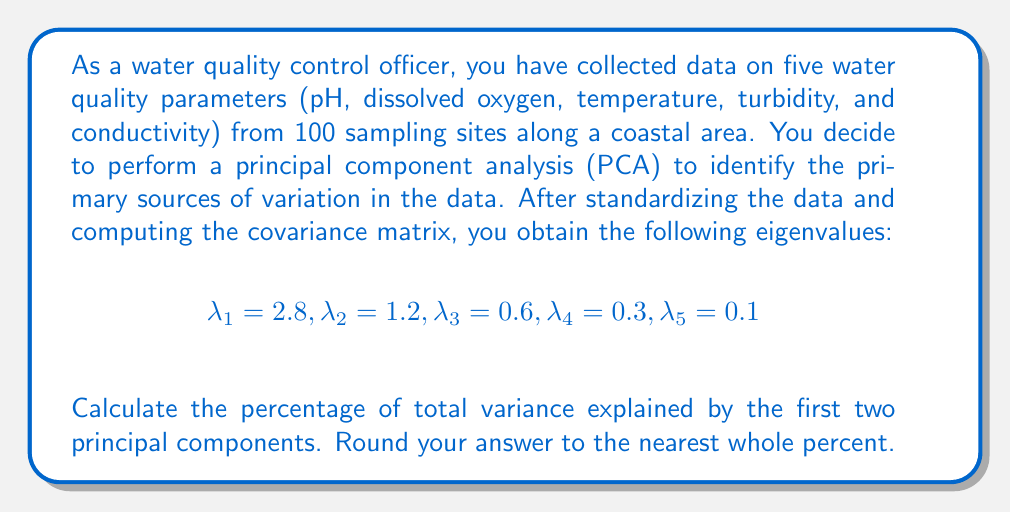Can you answer this question? To solve this problem, we need to follow these steps:

1) First, recall that in PCA, each eigenvalue represents the amount of variance explained by its corresponding principal component.

2) The total variance in the dataset is equal to the sum of all eigenvalues:

   $$\text{Total Variance} = \sum_{i=1}^5 \lambda_i = 2.8 + 1.2 + 0.6 + 0.3 + 0.1 = 5$$

3) The variance explained by the first two principal components is the sum of their corresponding eigenvalues:

   $$\text{Variance of PC1 and PC2} = \lambda_1 + \lambda_2 = 2.8 + 1.2 = 4$$

4) To calculate the percentage of total variance explained by the first two principal components, we divide the variance of PC1 and PC2 by the total variance and multiply by 100:

   $$\text{Percentage} = \frac{\text{Variance of PC1 and PC2}}{\text{Total Variance}} \times 100\%$$

   $$= \frac{4}{5} \times 100\% = 80\%$$

5) Rounding to the nearest whole percent gives us 80%.

This result indicates that the first two principal components account for 80% of the total variation in the water quality data, suggesting that these two components capture most of the important information in the dataset.
Answer: 80% 